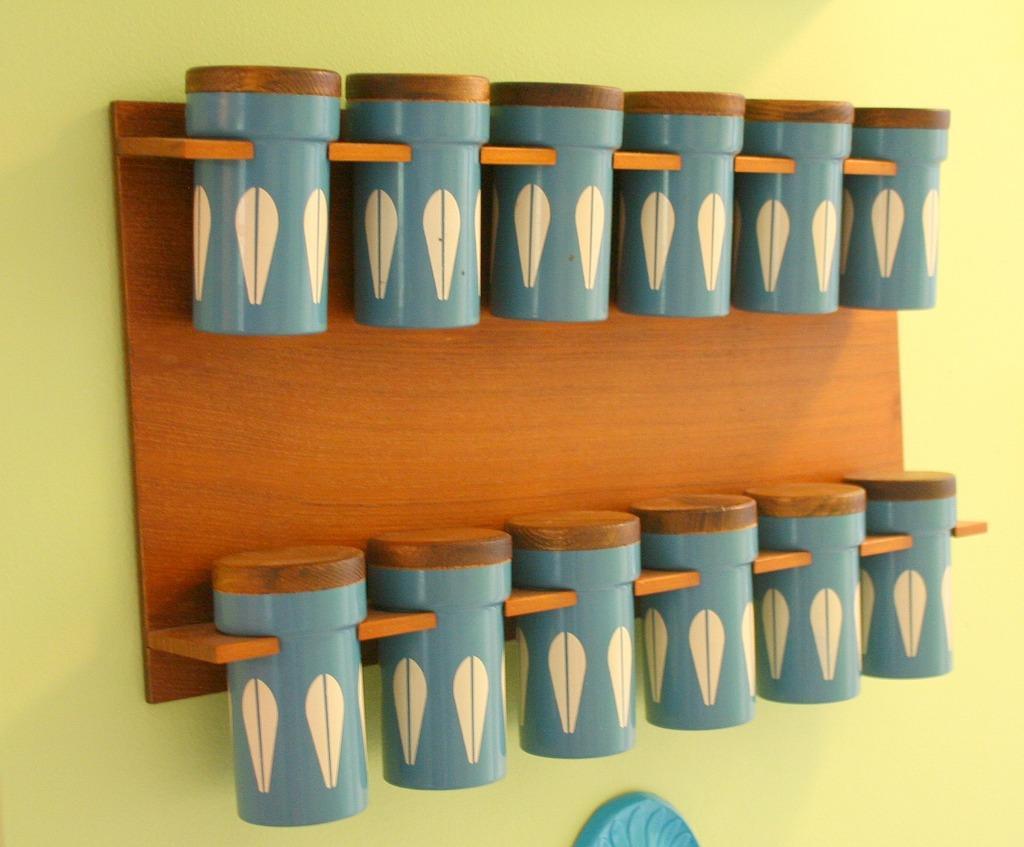Please provide a concise description of this image. This image consists of some boxes. They are attached to the wall. They are in blue color. 